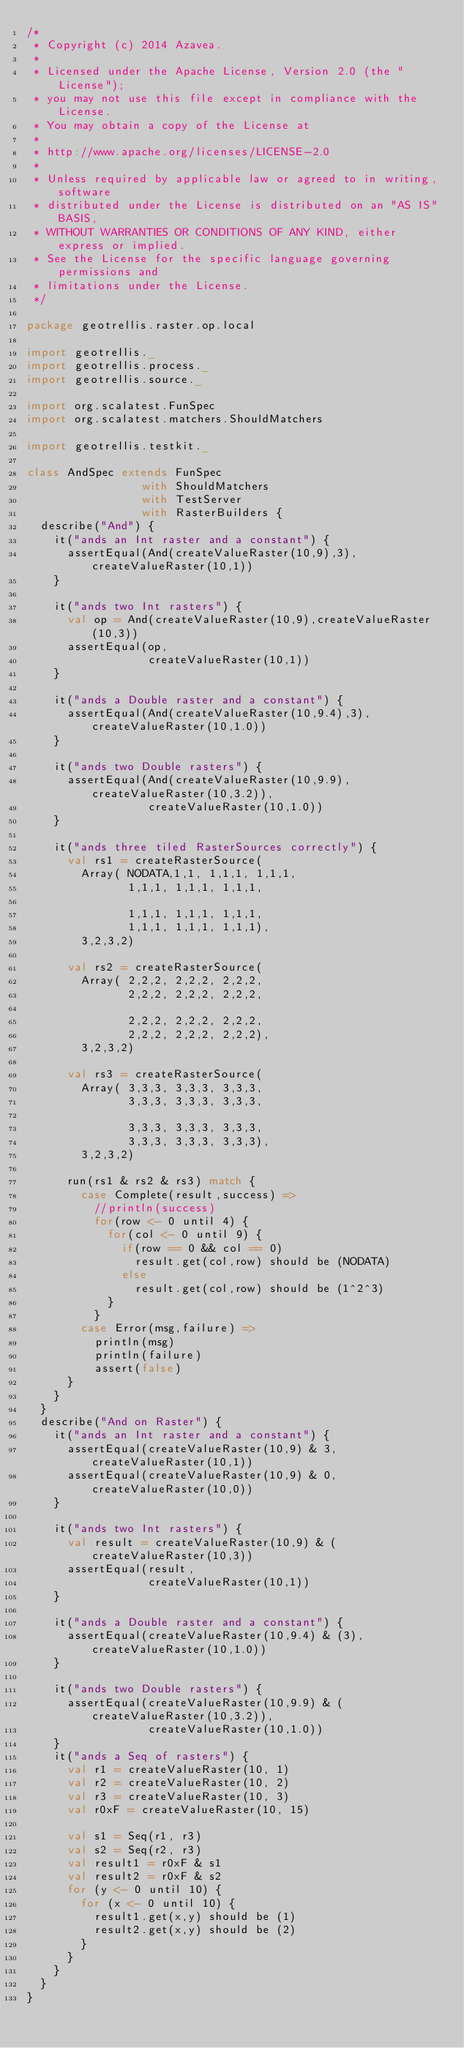Convert code to text. <code><loc_0><loc_0><loc_500><loc_500><_Scala_>/*
 * Copyright (c) 2014 Azavea.
 * 
 * Licensed under the Apache License, Version 2.0 (the "License");
 * you may not use this file except in compliance with the License.
 * You may obtain a copy of the License at
 * 
 * http://www.apache.org/licenses/LICENSE-2.0
 * 
 * Unless required by applicable law or agreed to in writing, software
 * distributed under the License is distributed on an "AS IS" BASIS,
 * WITHOUT WARRANTIES OR CONDITIONS OF ANY KIND, either express or implied.
 * See the License for the specific language governing permissions and
 * limitations under the License.
 */

package geotrellis.raster.op.local

import geotrellis._
import geotrellis.process._
import geotrellis.source._

import org.scalatest.FunSpec
import org.scalatest.matchers.ShouldMatchers

import geotrellis.testkit._

class AndSpec extends FunSpec 
                 with ShouldMatchers 
                 with TestServer 
                 with RasterBuilders {
  describe("And") {
    it("ands an Int raster and a constant") {
      assertEqual(And(createValueRaster(10,9),3), createValueRaster(10,1))
    }

    it("ands two Int rasters") {
      val op = And(createValueRaster(10,9),createValueRaster(10,3))
      assertEqual(op, 
                  createValueRaster(10,1))
    }

    it("ands a Double raster and a constant") {
      assertEqual(And(createValueRaster(10,9.4),3), createValueRaster(10,1.0))
    }

    it("ands two Double rasters") {
      assertEqual(And(createValueRaster(10,9.9),createValueRaster(10,3.2)), 
                  createValueRaster(10,1.0))
    }

    it("ands three tiled RasterSources correctly") {
      val rs1 = createRasterSource(
        Array( NODATA,1,1, 1,1,1, 1,1,1,
               1,1,1, 1,1,1, 1,1,1,

               1,1,1, 1,1,1, 1,1,1,
               1,1,1, 1,1,1, 1,1,1),
        3,2,3,2)

      val rs2 = createRasterSource(
        Array( 2,2,2, 2,2,2, 2,2,2,
               2,2,2, 2,2,2, 2,2,2,

               2,2,2, 2,2,2, 2,2,2,
               2,2,2, 2,2,2, 2,2,2),
        3,2,3,2)

      val rs3 = createRasterSource(
        Array( 3,3,3, 3,3,3, 3,3,3,
               3,3,3, 3,3,3, 3,3,3,

               3,3,3, 3,3,3, 3,3,3,
               3,3,3, 3,3,3, 3,3,3),
        3,2,3,2)

      run(rs1 & rs2 & rs3) match {
        case Complete(result,success) =>
          //println(success)
          for(row <- 0 until 4) {
            for(col <- 0 until 9) {
              if(row == 0 && col == 0)
                result.get(col,row) should be (NODATA)
              else
                result.get(col,row) should be (1^2^3)
            }
          }
        case Error(msg,failure) =>
          println(msg)
          println(failure)
          assert(false)
      }
    }
  }
  describe("And on Raster") {
    it("ands an Int raster and a constant") {
      assertEqual(createValueRaster(10,9) & 3, createValueRaster(10,1))
      assertEqual(createValueRaster(10,9) & 0, createValueRaster(10,0))
    }

    it("ands two Int rasters") {
      val result = createValueRaster(10,9) & (createValueRaster(10,3))
      assertEqual(result,
                  createValueRaster(10,1))
    }

    it("ands a Double raster and a constant") {
      assertEqual(createValueRaster(10,9.4) & (3), createValueRaster(10,1.0))
    }

    it("ands two Double rasters") {
      assertEqual(createValueRaster(10,9.9) & (createValueRaster(10,3.2)),
                  createValueRaster(10,1.0))
    }
    it("ands a Seq of rasters") {
      val r1 = createValueRaster(10, 1)
      val r2 = createValueRaster(10, 2)
      val r3 = createValueRaster(10, 3)
      val r0xF = createValueRaster(10, 15)

      val s1 = Seq(r1, r3)
      val s2 = Seq(r2, r3)
      val result1 = r0xF & s1
      val result2 = r0xF & s2
      for (y <- 0 until 10) {
        for (x <- 0 until 10) {
          result1.get(x,y) should be (1)
          result2.get(x,y) should be (2)
        }
      }
    }
  }
}
</code> 